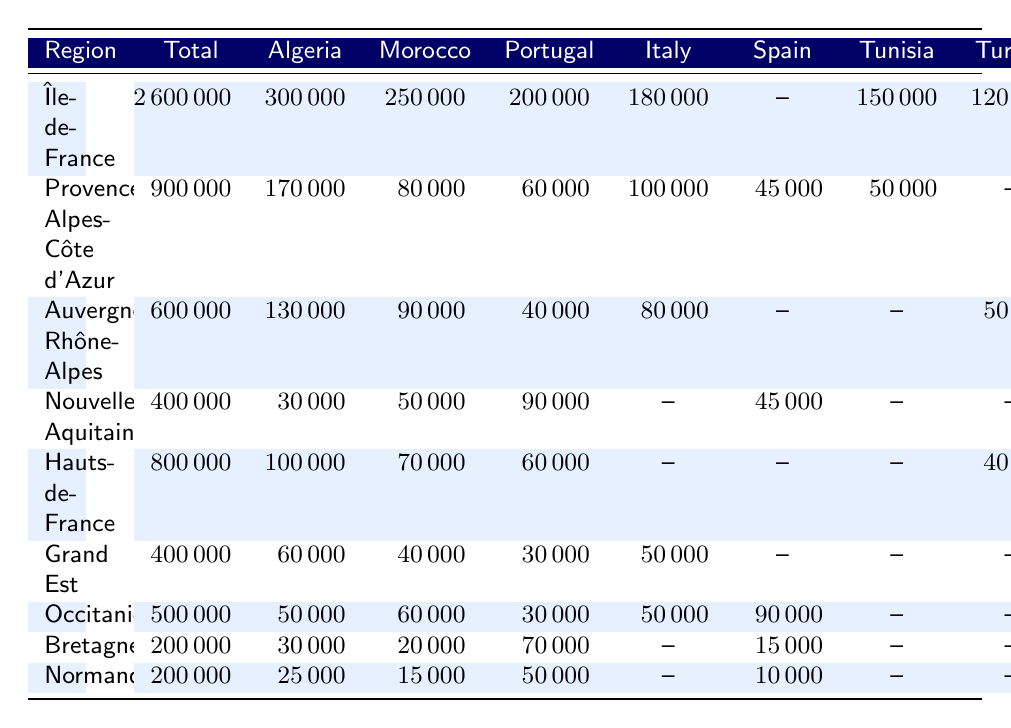What is the total number of immigrants in Île-de-France? The table shows that the total number of immigrants in Île-de-France is listed under the "Total" column for this region, which reads 2600000.
Answer: 2600000 How many Moroccan immigrants are there in Provence-Alpes-Côte d'Azur? The number of Moroccan immigrants in Provence-Alpes-Côte d'Azur can be found in the "Morocco" column corresponding to this region, which indicates a count of 80000.
Answer: 80000 Which region has the highest number of Algerian immigrants? By comparing the "Algeria" column across all regions, it's clear that Île-de-France has the highest number at 300000.
Answer: Île-de-France What is the total number of immigrants from Turkey across all regions? The numbers for Turkish immigrants can be found in the "Turkey" column: Île-de-France (120000), Provence-Alpes-Côte d'Azur (0), Auvergne-Rhône-Alpes (50000), Hauts-de-France (40000), and 0 in other regions. Summing these gives 120000 + 0 + 50000 + 40000 + 0 = 210000.
Answer: 210000 Is the total number of immigrants in Grand Est greater than 500000? The table indicates that the total number of immigrants in Grand Est is 400000, which is less than 500000.
Answer: No What percentage of immigrants in Occitanie are from Spain? To find this percentage, divide the number of Spanish immigrants (90000) by the total number of immigrants in Occitanie (500000) and multiply by 100: (90000/500000) * 100 = 18%.
Answer: 18% How many more immigrants are there in Hauts-de-France than in Nouvelle-Aquitaine? The total number of immigrants in Hauts-de-France is 800000 and in Nouvelle-Aquitaine is 400000. To find the difference: 800000 - 400000 = 400000.
Answer: 400000 What is the total number of Sub-Saharan African immigrants in all regions? The numbers for Sub-Saharan African immigrants are as follows: Île-de-France (300000), Provence-Alpes-Côte d'Azur (70000), Auvergne-Rhône-Alpes (40000), Nouvelle-Aquitaine (20000), Hauts-de-France (50000), Grand Est (30000), Occitanie (40000), Bretagne (10000), and Normandie (8000). Summing these gives 300000 + 70000 + 40000 + 20000 + 50000 + 30000 + 40000 + 10000 + 8000 = 585000.
Answer: 585000 Which regions have fewer than 300000 total immigrants? Looking at the "Total" column, we see that Bretagne and Normandie both have 200000 immigrants, which is fewer than 300000.
Answer: Bretagne, Normandie Are there more Italian immigrants in Île-de-France or Auvergne-Rhône-Alpes? In Île-de-France, there are 180000 Italian immigrants and in Auvergne-Rhône-Alpes, there are 80000. Since 180000 is greater than 80000, there are more in Île-de-France.
Answer: Île-de-France 